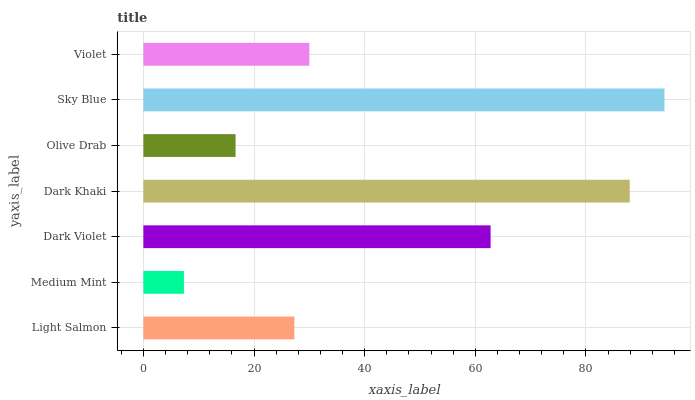Is Medium Mint the minimum?
Answer yes or no. Yes. Is Sky Blue the maximum?
Answer yes or no. Yes. Is Dark Violet the minimum?
Answer yes or no. No. Is Dark Violet the maximum?
Answer yes or no. No. Is Dark Violet greater than Medium Mint?
Answer yes or no. Yes. Is Medium Mint less than Dark Violet?
Answer yes or no. Yes. Is Medium Mint greater than Dark Violet?
Answer yes or no. No. Is Dark Violet less than Medium Mint?
Answer yes or no. No. Is Violet the high median?
Answer yes or no. Yes. Is Violet the low median?
Answer yes or no. Yes. Is Light Salmon the high median?
Answer yes or no. No. Is Sky Blue the low median?
Answer yes or no. No. 